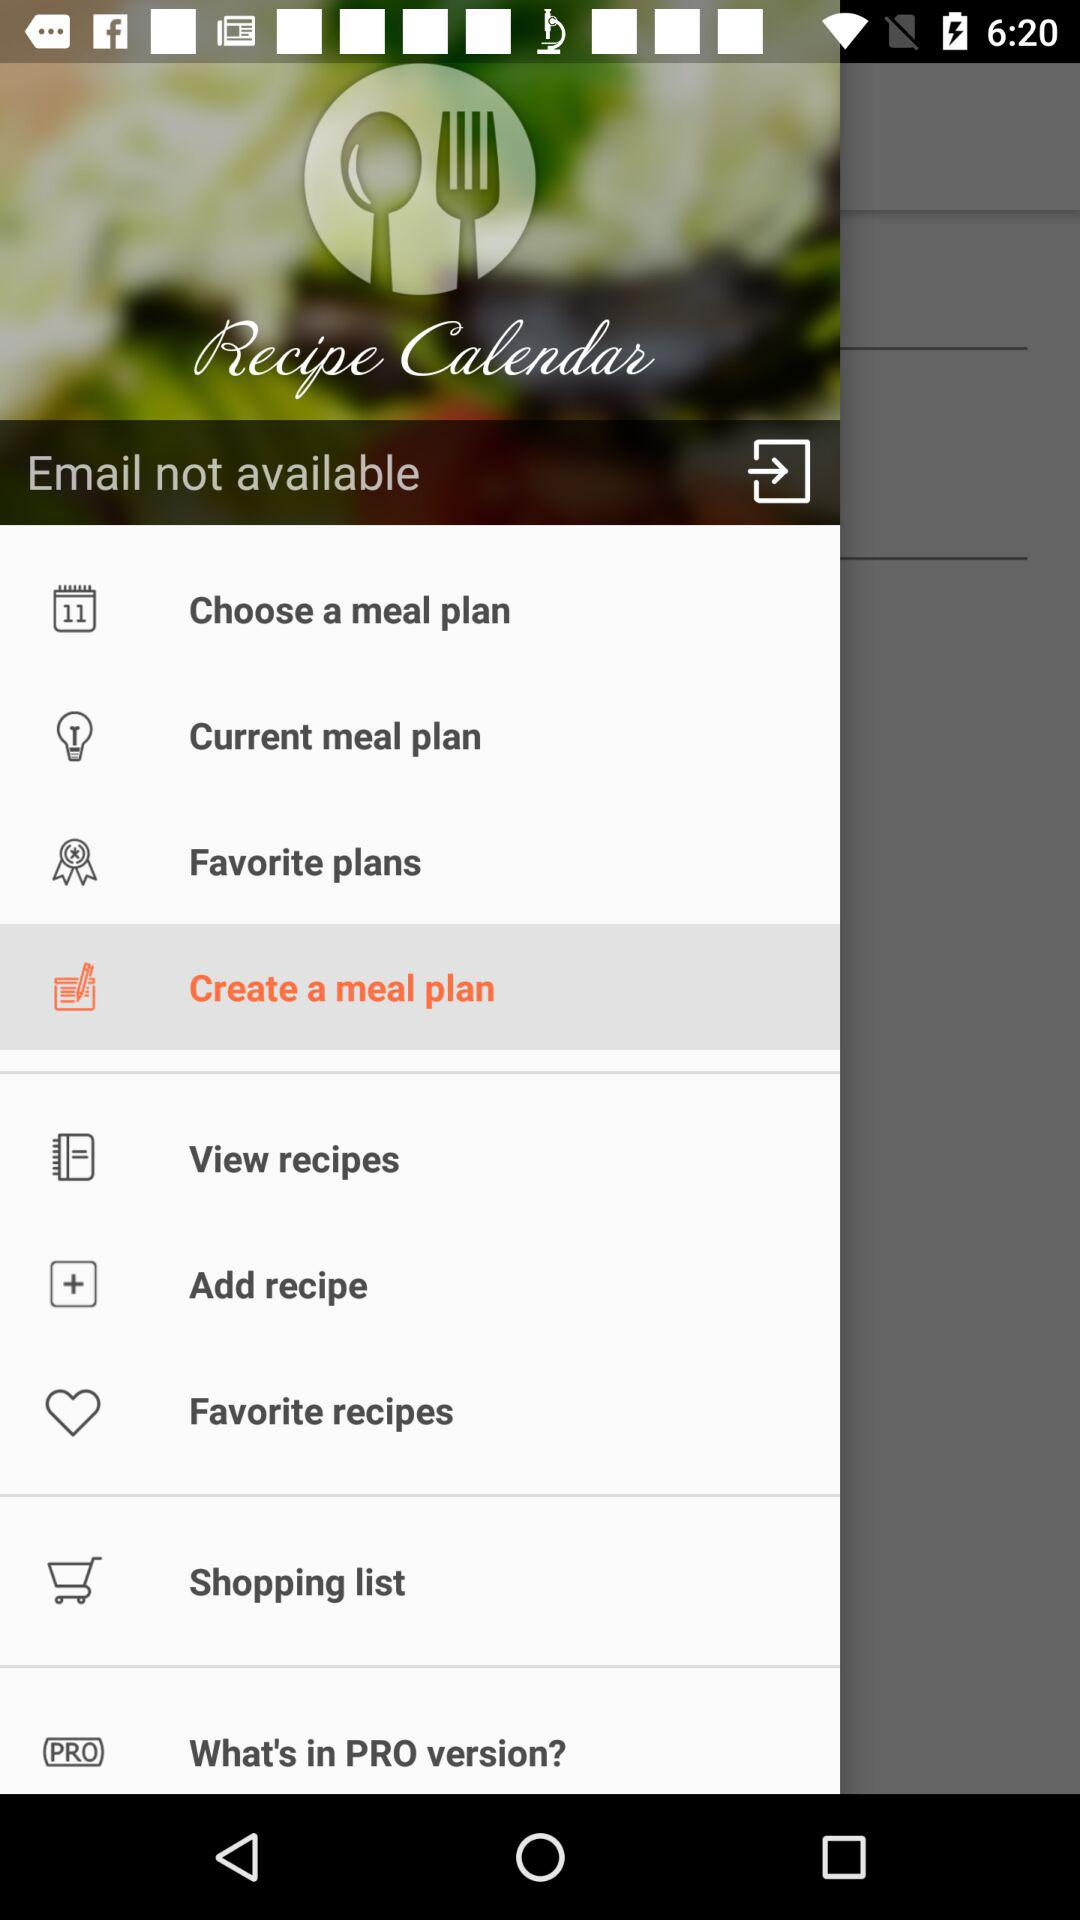What is not available? The email is not available. 